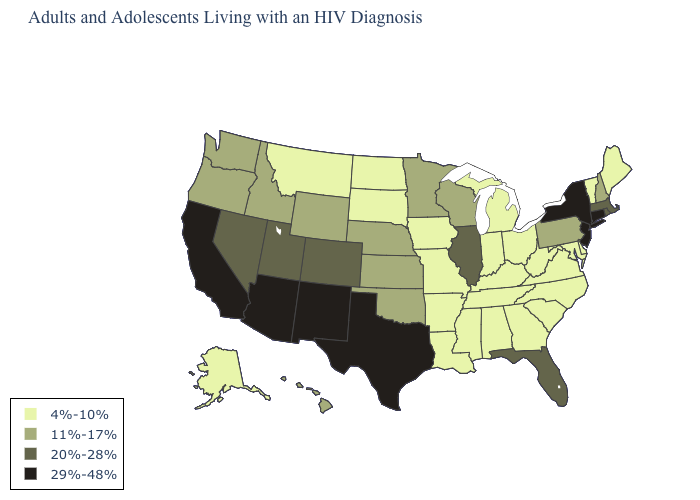Does Michigan have the highest value in the USA?
Concise answer only. No. Which states hav the highest value in the West?
Give a very brief answer. Arizona, California, New Mexico. Name the states that have a value in the range 4%-10%?
Answer briefly. Alabama, Alaska, Arkansas, Delaware, Georgia, Indiana, Iowa, Kentucky, Louisiana, Maine, Maryland, Michigan, Mississippi, Missouri, Montana, North Carolina, North Dakota, Ohio, South Carolina, South Dakota, Tennessee, Vermont, Virginia, West Virginia. What is the highest value in states that border Rhode Island?
Concise answer only. 29%-48%. Does Washington have the lowest value in the USA?
Concise answer only. No. Which states hav the highest value in the South?
Quick response, please. Texas. Name the states that have a value in the range 4%-10%?
Answer briefly. Alabama, Alaska, Arkansas, Delaware, Georgia, Indiana, Iowa, Kentucky, Louisiana, Maine, Maryland, Michigan, Mississippi, Missouri, Montana, North Carolina, North Dakota, Ohio, South Carolina, South Dakota, Tennessee, Vermont, Virginia, West Virginia. What is the value of Nebraska?
Answer briefly. 11%-17%. What is the value of Colorado?
Answer briefly. 20%-28%. Is the legend a continuous bar?
Answer briefly. No. Among the states that border Georgia , does Florida have the highest value?
Keep it brief. Yes. What is the value of Alaska?
Give a very brief answer. 4%-10%. What is the highest value in the West ?
Be succinct. 29%-48%. Does Ohio have the same value as New Mexico?
Short answer required. No. 